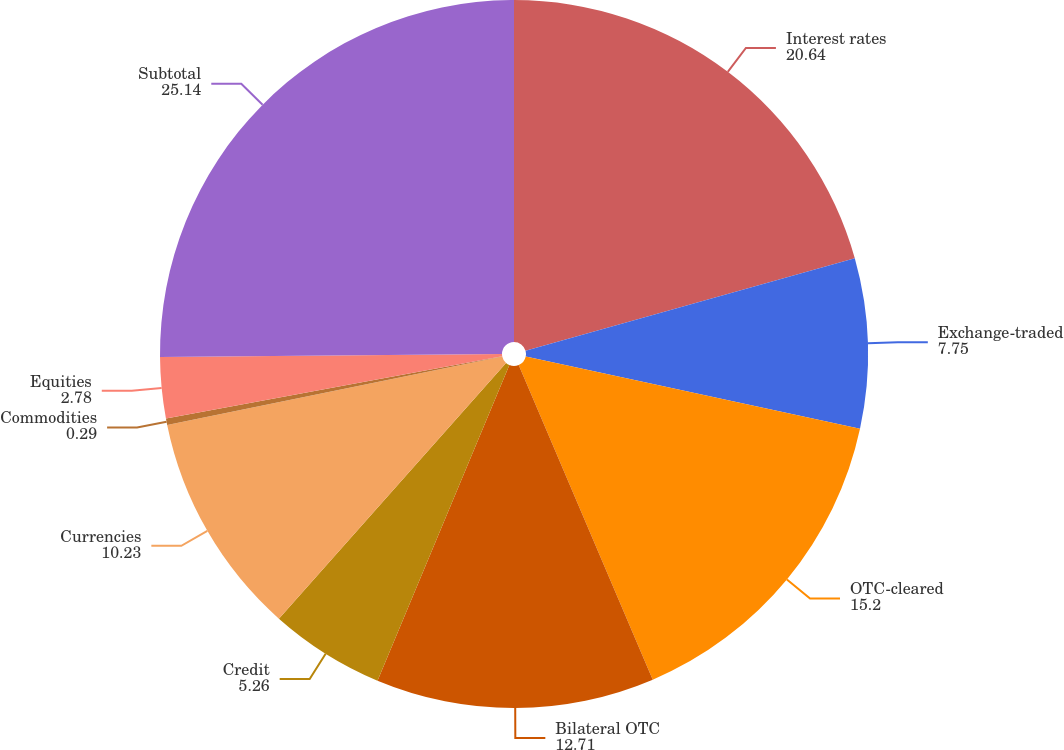<chart> <loc_0><loc_0><loc_500><loc_500><pie_chart><fcel>Interest rates<fcel>Exchange-traded<fcel>OTC-cleared<fcel>Bilateral OTC<fcel>Credit<fcel>Currencies<fcel>Commodities<fcel>Equities<fcel>Subtotal<nl><fcel>20.64%<fcel>7.75%<fcel>15.2%<fcel>12.71%<fcel>5.26%<fcel>10.23%<fcel>0.29%<fcel>2.78%<fcel>25.14%<nl></chart> 